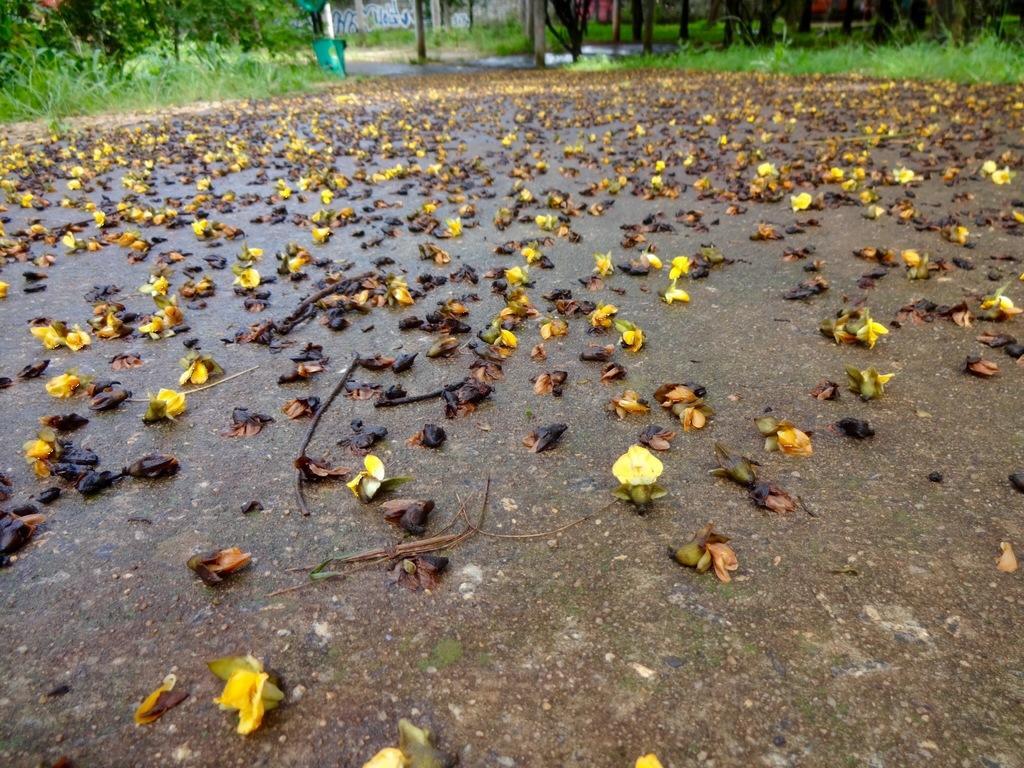Can you describe this image briefly? At the bottom of the image on the road there are flowers. In the background there is grass and also there are tree trunks. 